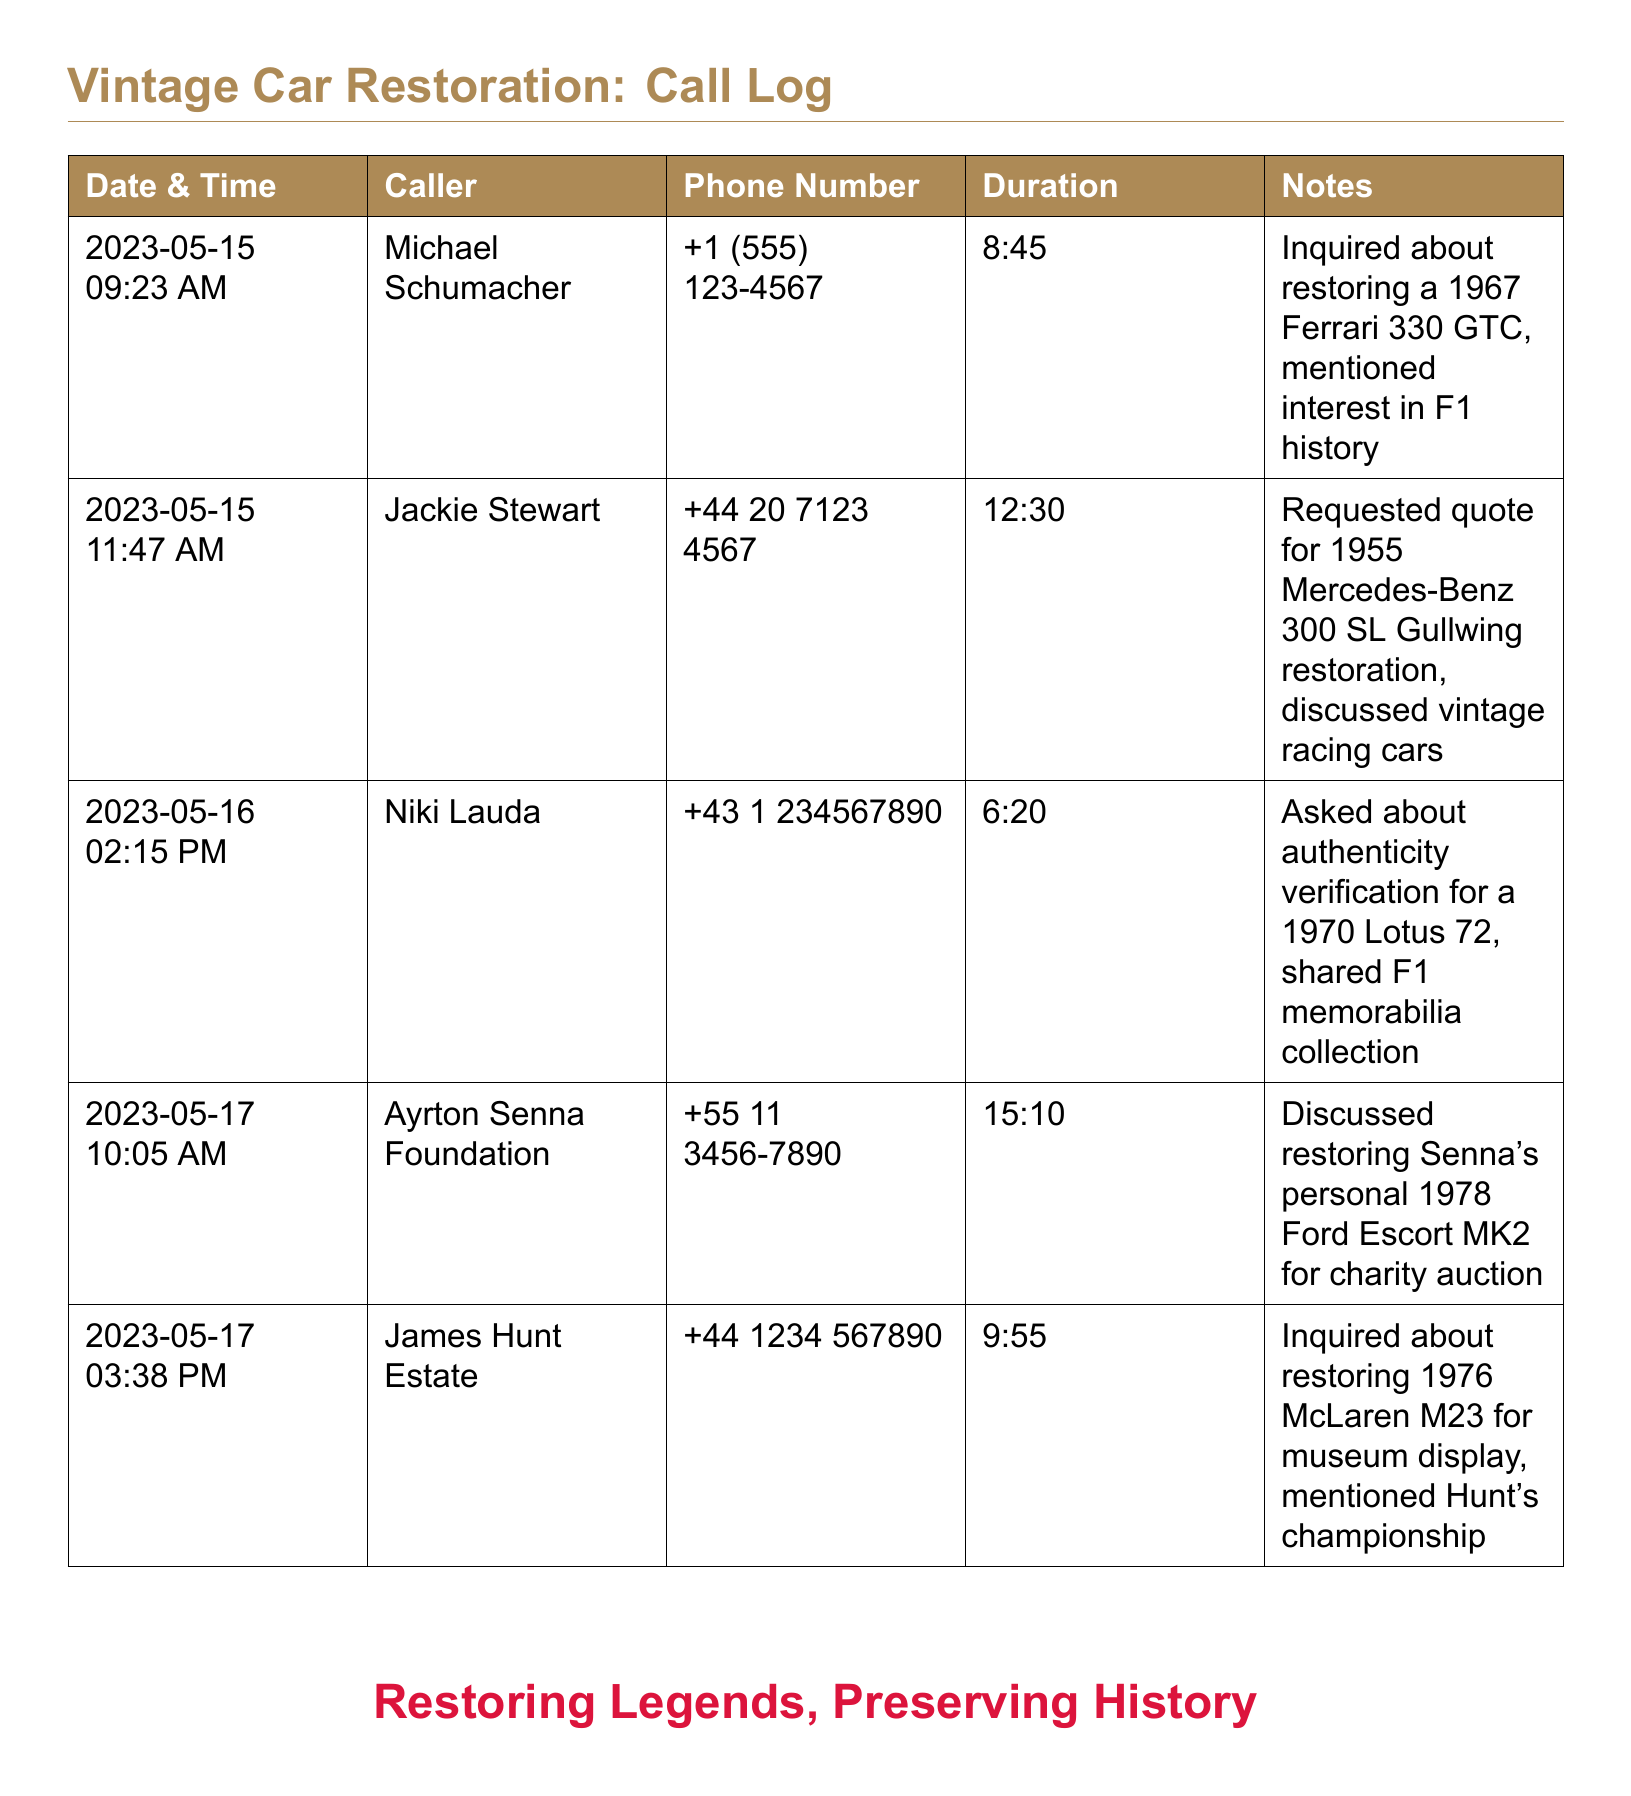What is the date of the first call? The date of the first call listed in the document is found in the first row of the call log section.
Answer: 2023-05-15 Who called about the 1955 Mercedes-Benz restoration? This information can be retrieved from the second row of the table where it mentions the caller’s name associated with the inquiry about that specific vehicle.
Answer: Jackie Stewart What was the total duration of calls from May 17? The total duration is calculated by summing the durations from the calls made on May 17, as listed in the document.
Answer: 25:05 How long was the call regarding authenticity verification for a Lotus? The relevant information is found in the third row, which indicates the duration of that particular call.
Answer: 6:20 What is the phone number for Michael Schumacher? This can be directly found next to his name in the call log, indicating the contact number provided during the inquiry.
Answer: +1 (555) 123-4567 How many calls were made on May 17? The number of calls can be determined by counting the entries in the log that list the date as May 17.
Answer: 2 What car was discussed by the Ayrton Senna Foundation? The specific vehicle is mentioned in the notes section of the corresponding entry for that call.
Answer: 1978 Ford Escort MK2 Which caller mentioned interest in Formula One history? This detail is mentioned in the notes section alongside the caller’s name on the relevant row.
Answer: Michael Schumacher What was the duration of the call for the 1976 McLaren M23 restoration? This is available in the row that pertains to the inquiry about restoring the specific car, outlining the duration of that communication.
Answer: 9:55 